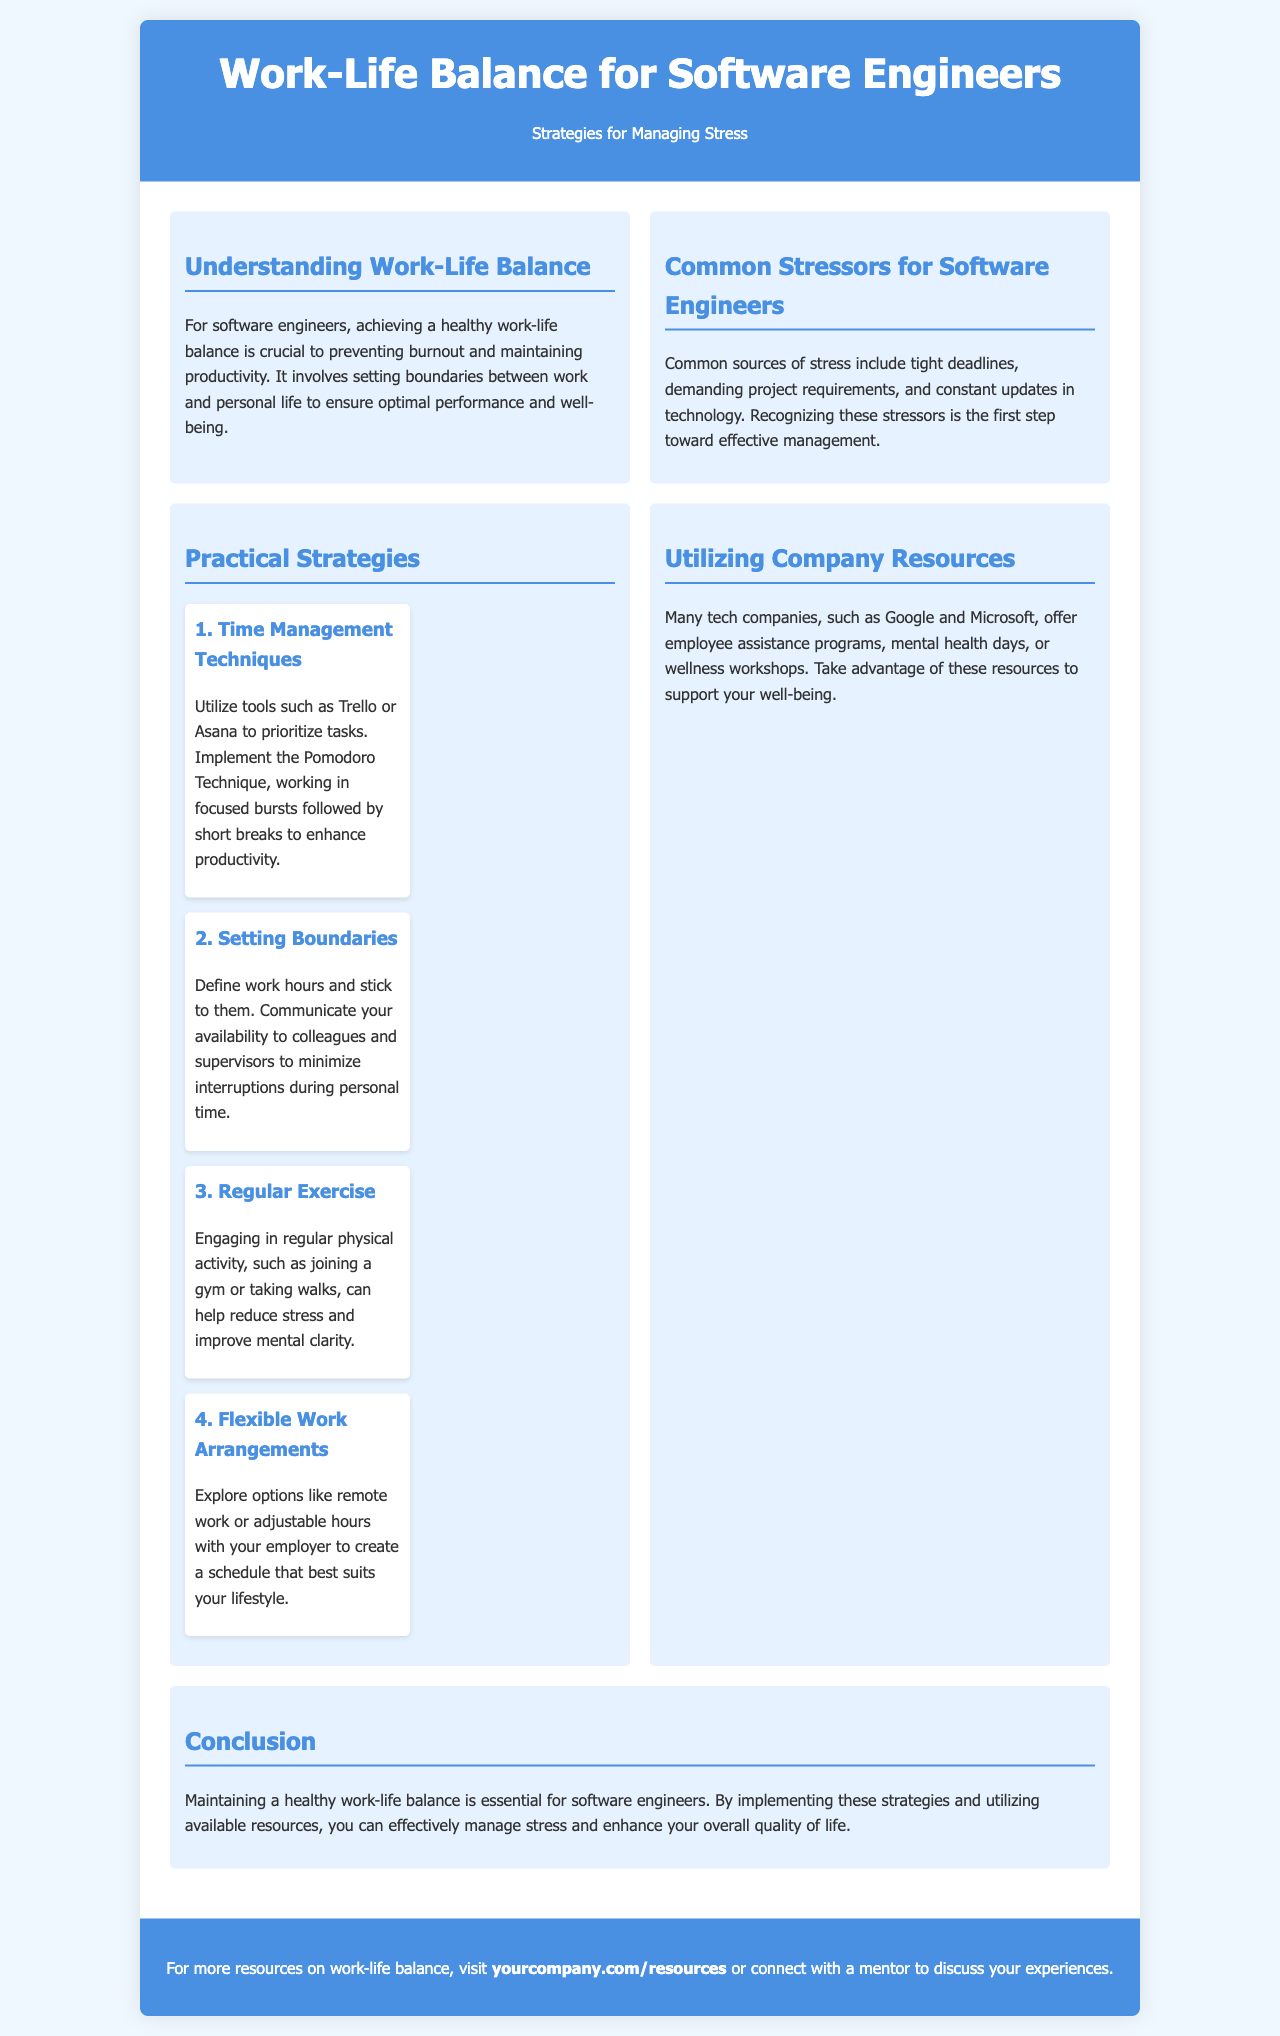what is the title of the brochure? The title of the brochure is presented prominently at the top of the document.
Answer: Work-Life Balance for Software Engineers what is one common source of stress for software engineers? The document lists specific examples of stressors faced by software engineers in one of the sections.
Answer: Tight deadlines what is one time management technique mentioned? The brochure provides specific strategies within the section dedicated to practical strategies.
Answer: Pomodoro Technique what are two benefits of regular exercise according to the brochure? The text outlines the positive effects of exercise on stress and mental clarity in one of the strategies.
Answer: Reduce stress and improve mental clarity which companies offer employee assistance programs? The resources provided by companies are mentioned in the section discussing company resources.
Answer: Google and Microsoft how many practical strategies are included in the brochure? The strategies section details several strategies aimed at managing stress for software engineers.
Answer: Four what is a suggested flexible work arrangement for software engineers? The brochure refers to several options under the flexible work arrangements strategy.
Answer: Remote work which color is primarily used in the header? The color scheme used in the brochure is described in the header section of the document.
Answer: Blue what is a call to action at the end of the brochure? The document encourages readers to take specific actions and offers resources in the call-to-action section.
Answer: Visit yourcompany.com/resources 